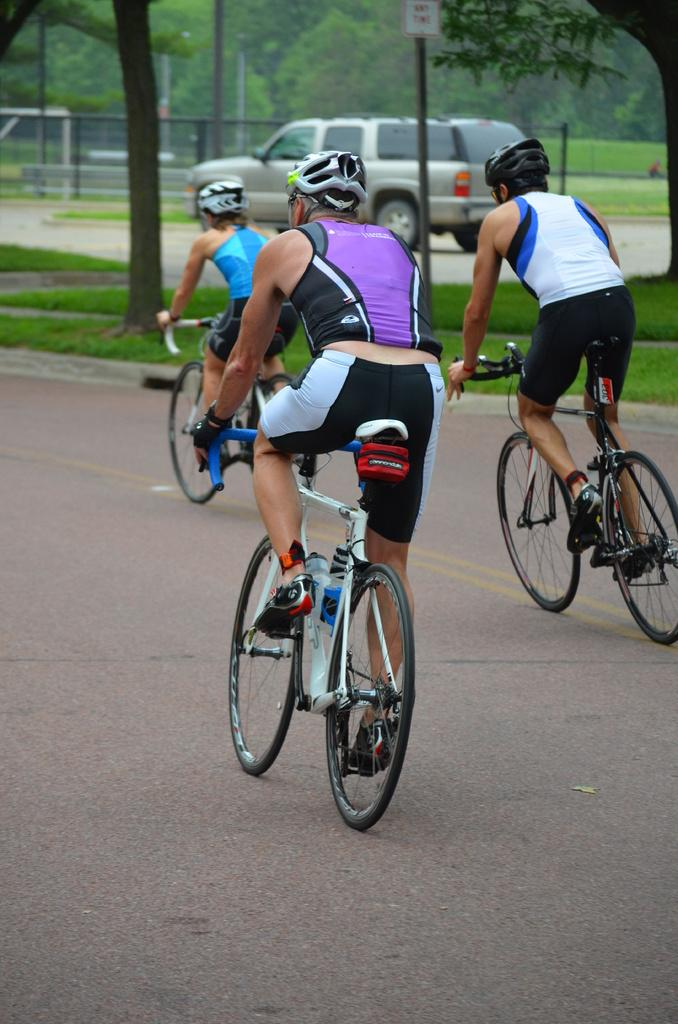How many people are in the image? There are three persons in the image. What are the persons doing in the image? The persons are riding a bicycle. What safety precautions are the persons taking? The persons are wearing helmets. What type of surface can be seen in the image? There is a road in the image. What type of vegetation is visible in the background? There are trees visible in the background. What else can be seen in the background? There are cars visible in the background. What type of ground is present in the image? There is grass in the image. What channel is the middle person watching on the bicycle? There is no television or channel present in the image; the persons are riding a bicycle. 